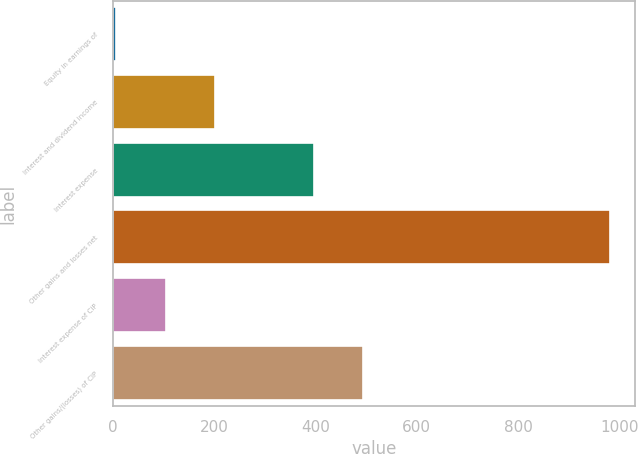Convert chart to OTSL. <chart><loc_0><loc_0><loc_500><loc_500><bar_chart><fcel>Equity in earnings of<fcel>Interest and dividend income<fcel>Interest expense<fcel>Other gains and losses net<fcel>Interest expense of CIP<fcel>Other gains/(losses) of CIP<nl><fcel>7.6<fcel>202.24<fcel>396.88<fcel>980.8<fcel>104.92<fcel>494.2<nl></chart> 